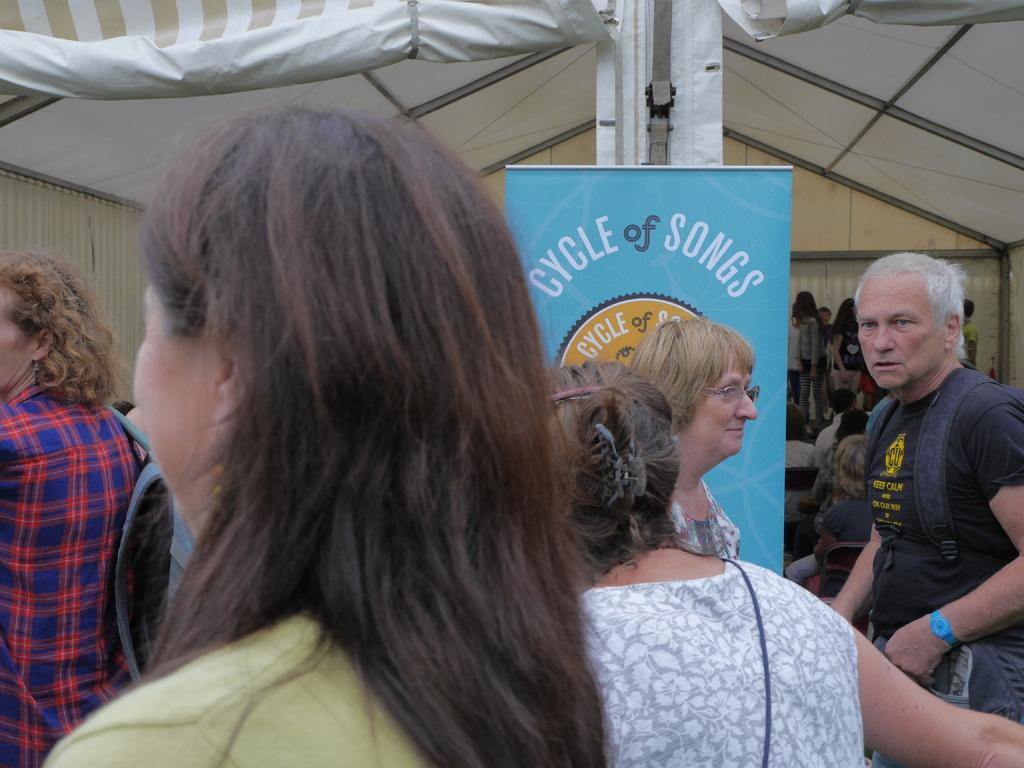How many people are in the image? There is a group of people in the image, but the exact number cannot be determined from the provided facts. What can be seen in the background of the image? There is written text visible in the background of the image. What type of celery is being used as a prop by the expert in the mine in the image? There is no mine, expert, or celery present in the image. 